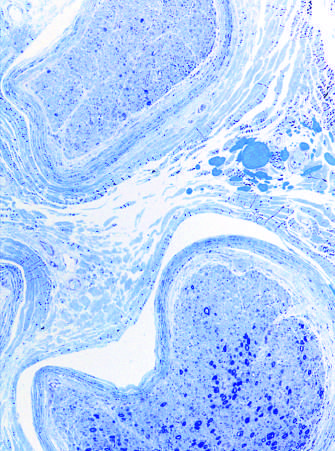s failure to stain often seen in neuropathies resulting from vascular injury?
Answer the question using a single word or phrase. No 